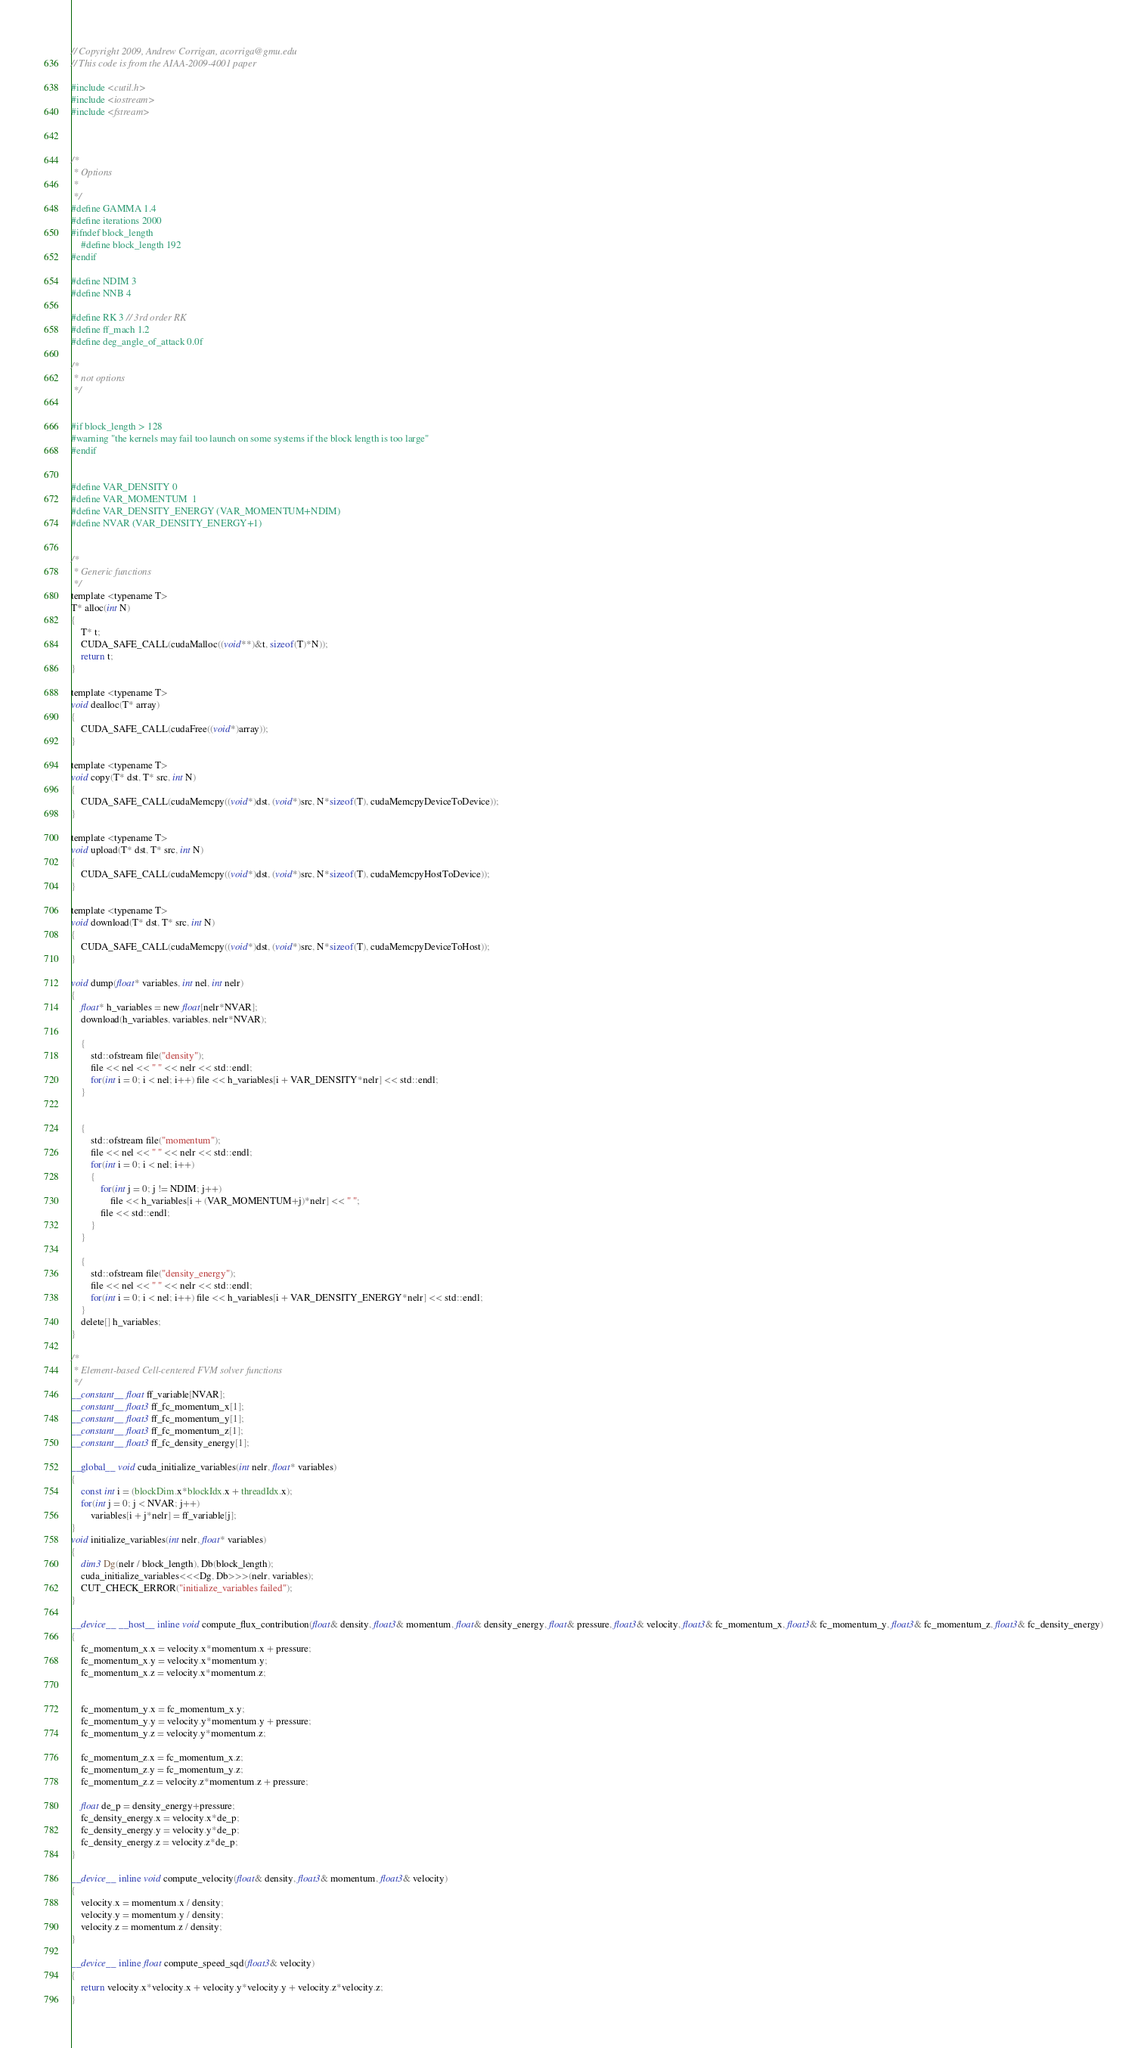<code> <loc_0><loc_0><loc_500><loc_500><_Cuda_>// Copyright 2009, Andrew Corrigan, acorriga@gmu.edu
// This code is from the AIAA-2009-4001 paper

#include <cutil.h>
#include <iostream>
#include <fstream>

 
 
/*
 * Options 
 * 
 */ 
#define GAMMA 1.4
#define iterations 2000
#ifndef block_length
	#define block_length 192
#endif

#define NDIM 3
#define NNB 4

#define RK 3	// 3rd order RK
#define ff_mach 1.2
#define deg_angle_of_attack 0.0f

/*
 * not options
 */


#if block_length > 128
#warning "the kernels may fail too launch on some systems if the block length is too large"
#endif


#define VAR_DENSITY 0
#define VAR_MOMENTUM  1
#define VAR_DENSITY_ENERGY (VAR_MOMENTUM+NDIM)
#define NVAR (VAR_DENSITY_ENERGY+1)


/*
 * Generic functions
 */
template <typename T>
T* alloc(int N)
{
	T* t;
	CUDA_SAFE_CALL(cudaMalloc((void**)&t, sizeof(T)*N));
	return t;
}

template <typename T>
void dealloc(T* array)
{
	CUDA_SAFE_CALL(cudaFree((void*)array));
}

template <typename T>
void copy(T* dst, T* src, int N)
{
	CUDA_SAFE_CALL(cudaMemcpy((void*)dst, (void*)src, N*sizeof(T), cudaMemcpyDeviceToDevice));
}

template <typename T>
void upload(T* dst, T* src, int N)
{
	CUDA_SAFE_CALL(cudaMemcpy((void*)dst, (void*)src, N*sizeof(T), cudaMemcpyHostToDevice));
}

template <typename T>
void download(T* dst, T* src, int N)
{
	CUDA_SAFE_CALL(cudaMemcpy((void*)dst, (void*)src, N*sizeof(T), cudaMemcpyDeviceToHost));
}

void dump(float* variables, int nel, int nelr)
{
	float* h_variables = new float[nelr*NVAR];
	download(h_variables, variables, nelr*NVAR);

	{
		std::ofstream file("density");
		file << nel << " " << nelr << std::endl;
		for(int i = 0; i < nel; i++) file << h_variables[i + VAR_DENSITY*nelr] << std::endl;
	}


	{
		std::ofstream file("momentum");
		file << nel << " " << nelr << std::endl;
		for(int i = 0; i < nel; i++)
		{
			for(int j = 0; j != NDIM; j++)
				file << h_variables[i + (VAR_MOMENTUM+j)*nelr] << " ";
			file << std::endl;
		}
	}
	
	{
		std::ofstream file("density_energy");
		file << nel << " " << nelr << std::endl;
		for(int i = 0; i < nel; i++) file << h_variables[i + VAR_DENSITY_ENERGY*nelr] << std::endl;
	}
	delete[] h_variables;
}

/*
 * Element-based Cell-centered FVM solver functions
 */
__constant__ float ff_variable[NVAR];
__constant__ float3 ff_fc_momentum_x[1];
__constant__ float3 ff_fc_momentum_y[1];
__constant__ float3 ff_fc_momentum_z[1];
__constant__ float3 ff_fc_density_energy[1];

__global__ void cuda_initialize_variables(int nelr, float* variables)
{
	const int i = (blockDim.x*blockIdx.x + threadIdx.x);
	for(int j = 0; j < NVAR; j++)
		variables[i + j*nelr] = ff_variable[j];
}
void initialize_variables(int nelr, float* variables)
{
	dim3 Dg(nelr / block_length), Db(block_length);
	cuda_initialize_variables<<<Dg, Db>>>(nelr, variables);
	CUT_CHECK_ERROR("initialize_variables failed");
}

__device__ __host__ inline void compute_flux_contribution(float& density, float3& momentum, float& density_energy, float& pressure, float3& velocity, float3& fc_momentum_x, float3& fc_momentum_y, float3& fc_momentum_z, float3& fc_density_energy)
{
	fc_momentum_x.x = velocity.x*momentum.x + pressure;
	fc_momentum_x.y = velocity.x*momentum.y;
	fc_momentum_x.z = velocity.x*momentum.z;
	
	
	fc_momentum_y.x = fc_momentum_x.y;
	fc_momentum_y.y = velocity.y*momentum.y + pressure;
	fc_momentum_y.z = velocity.y*momentum.z;

	fc_momentum_z.x = fc_momentum_x.z;
	fc_momentum_z.y = fc_momentum_y.z;
	fc_momentum_z.z = velocity.z*momentum.z + pressure;

	float de_p = density_energy+pressure;
	fc_density_energy.x = velocity.x*de_p;
	fc_density_energy.y = velocity.y*de_p;
	fc_density_energy.z = velocity.z*de_p;
}

__device__ inline void compute_velocity(float& density, float3& momentum, float3& velocity)
{
	velocity.x = momentum.x / density;
	velocity.y = momentum.y / density;
	velocity.z = momentum.z / density;
}
	
__device__ inline float compute_speed_sqd(float3& velocity)
{
	return velocity.x*velocity.x + velocity.y*velocity.y + velocity.z*velocity.z;
}
</code> 